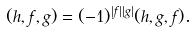Convert formula to latex. <formula><loc_0><loc_0><loc_500><loc_500>( h , f , g ) = ( - 1 ) ^ { | f | | g | } ( h , g , f ) .</formula> 